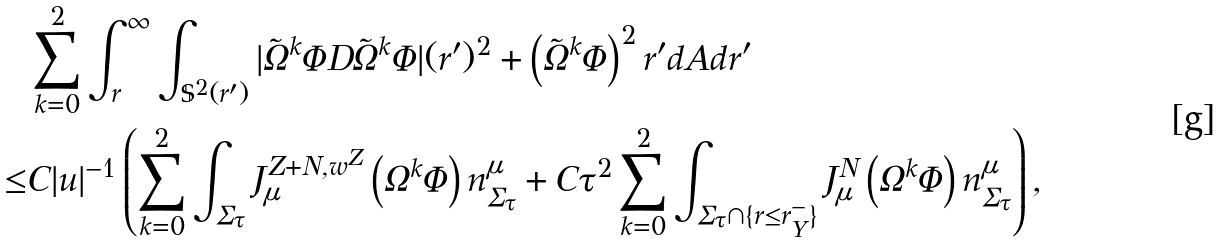Convert formula to latex. <formula><loc_0><loc_0><loc_500><loc_500>& \sum _ { k = 0 } ^ { 2 } \int ^ { \infty } _ { r } \int _ { \mathbb { S } ^ { 2 } ( r ^ { \prime } ) } | \tilde { \Omega } ^ { k } \Phi D \tilde { \Omega } ^ { k } \Phi | ( r ^ { \prime } ) ^ { 2 } + \left ( \tilde { \Omega } ^ { k } \Phi \right ) ^ { 2 } r ^ { \prime } d A d r ^ { \prime } \\ \leq & C | u | ^ { - 1 } \left ( \sum _ { k = 0 } ^ { 2 } \int _ { \Sigma _ { \tau } } J ^ { Z + N , w ^ { Z } } _ { \mu } \left ( \Omega ^ { k } \Phi \right ) n ^ { \mu } _ { \Sigma _ { \tau } } + C \tau ^ { 2 } \sum _ { k = 0 } ^ { 2 } \int _ { \Sigma _ { \tau } \cap \{ r \leq r ^ { - } _ { Y } \} } J ^ { N } _ { \mu } \left ( \Omega ^ { k } \Phi \right ) n ^ { \mu } _ { \Sigma _ { \tau } } \right ) ,</formula> 